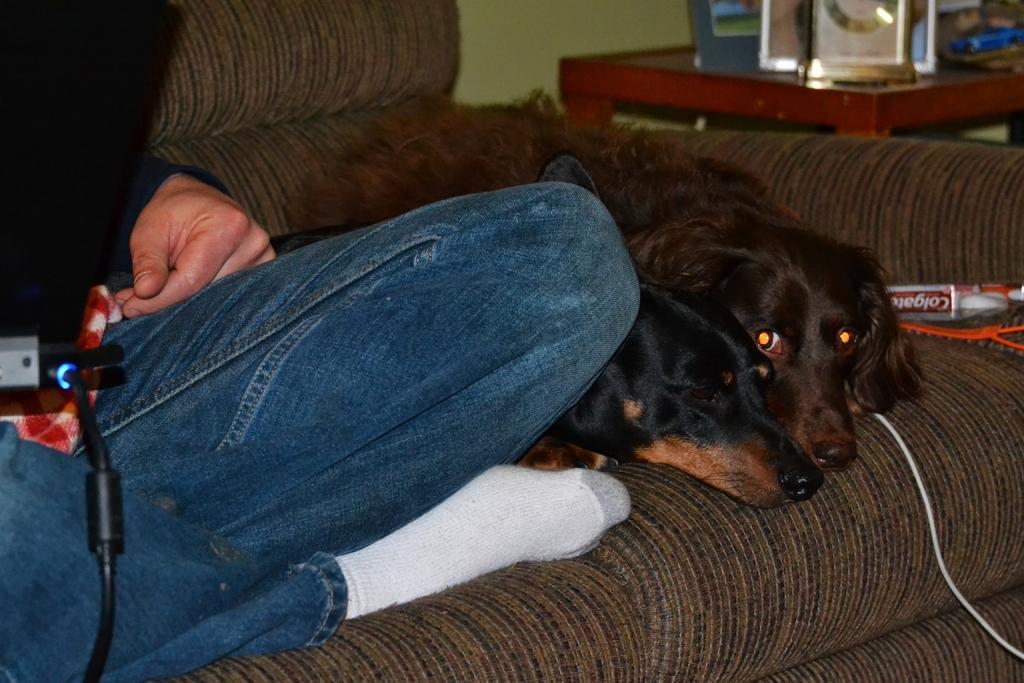Can you describe this image briefly? In this picture there is a man and two dogs on the sofa, in the center of the image and there is a desk at the top side of the image, on which there are frames and there is a wire on the right side of the image. 